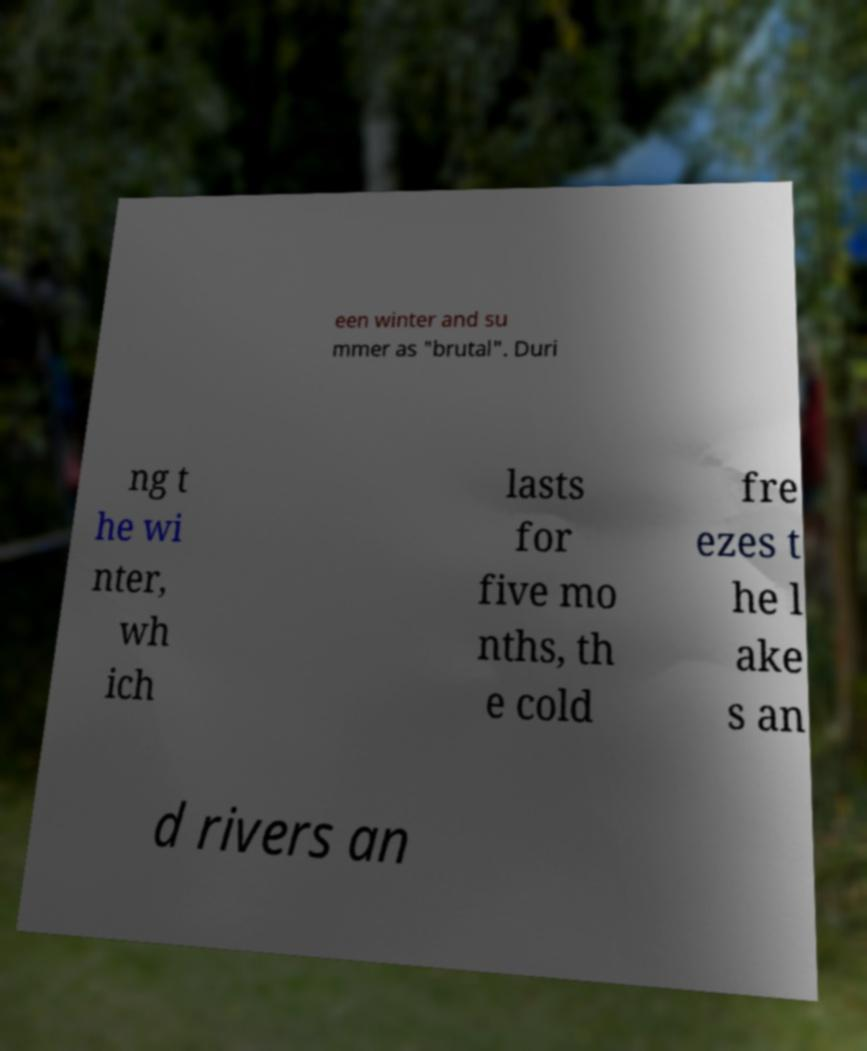Could you assist in decoding the text presented in this image and type it out clearly? een winter and su mmer as "brutal". Duri ng t he wi nter, wh ich lasts for five mo nths, th e cold fre ezes t he l ake s an d rivers an 